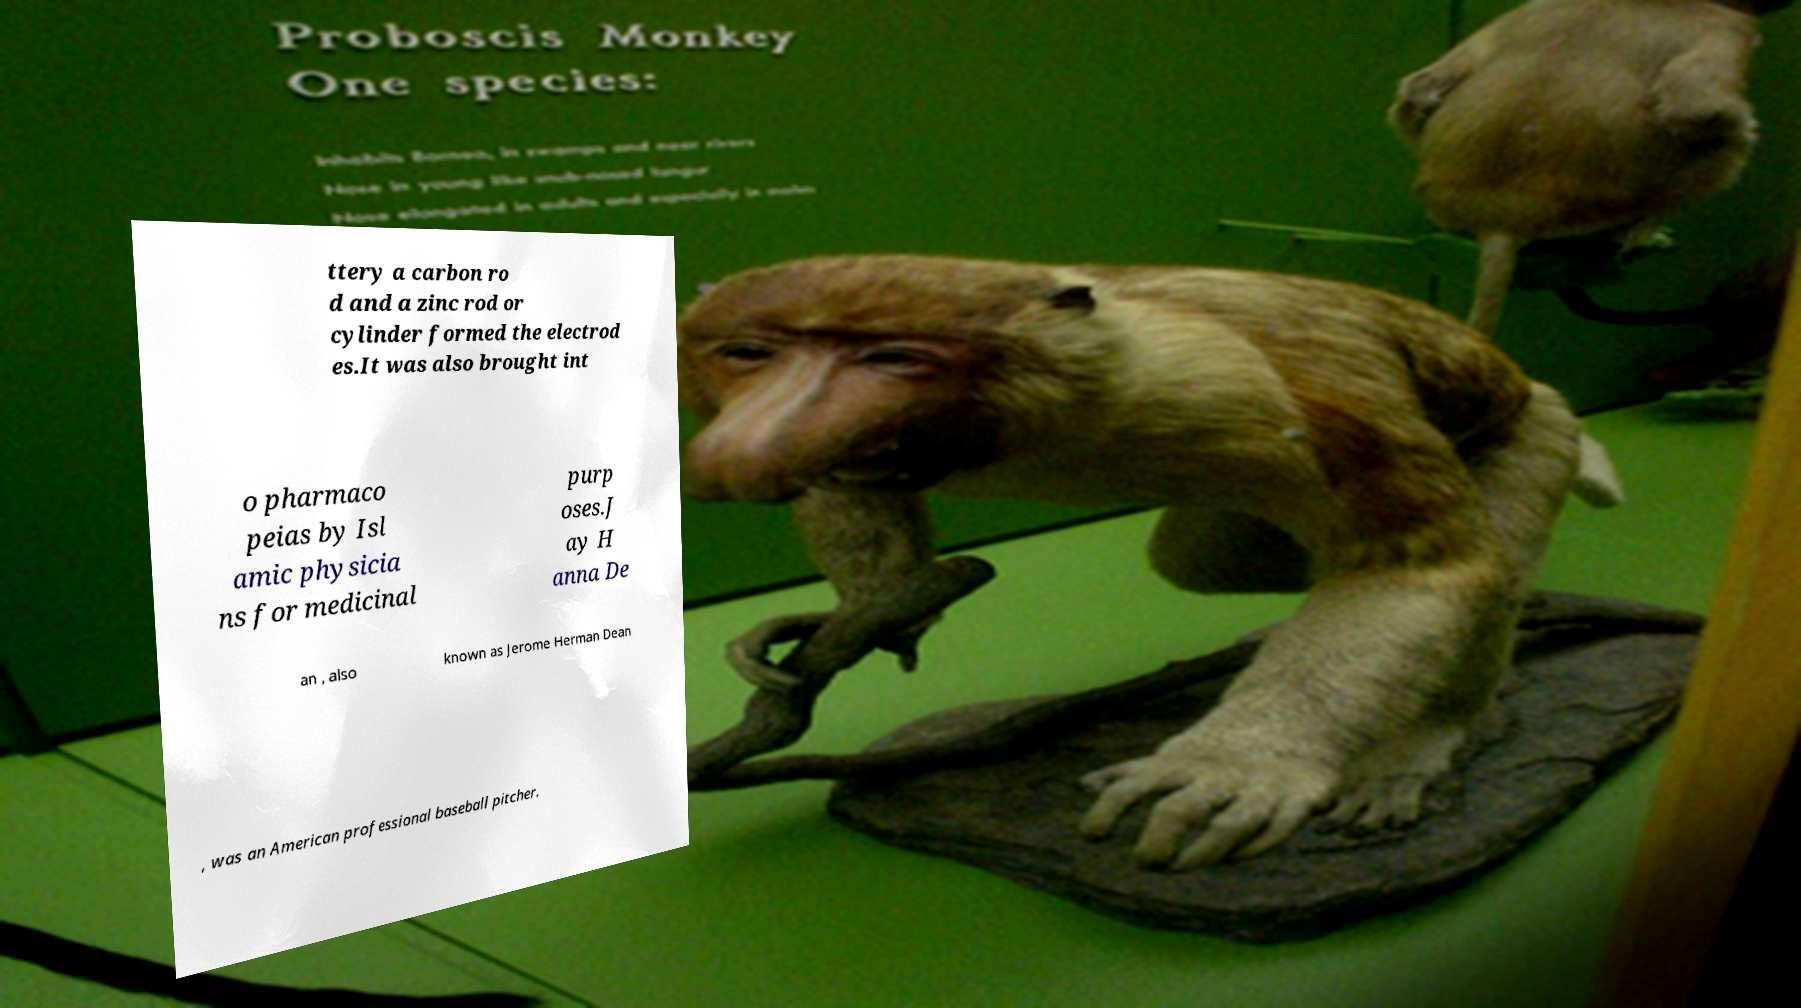Can you accurately transcribe the text from the provided image for me? ttery a carbon ro d and a zinc rod or cylinder formed the electrod es.It was also brought int o pharmaco peias by Isl amic physicia ns for medicinal purp oses.J ay H anna De an , also known as Jerome Herman Dean , was an American professional baseball pitcher. 